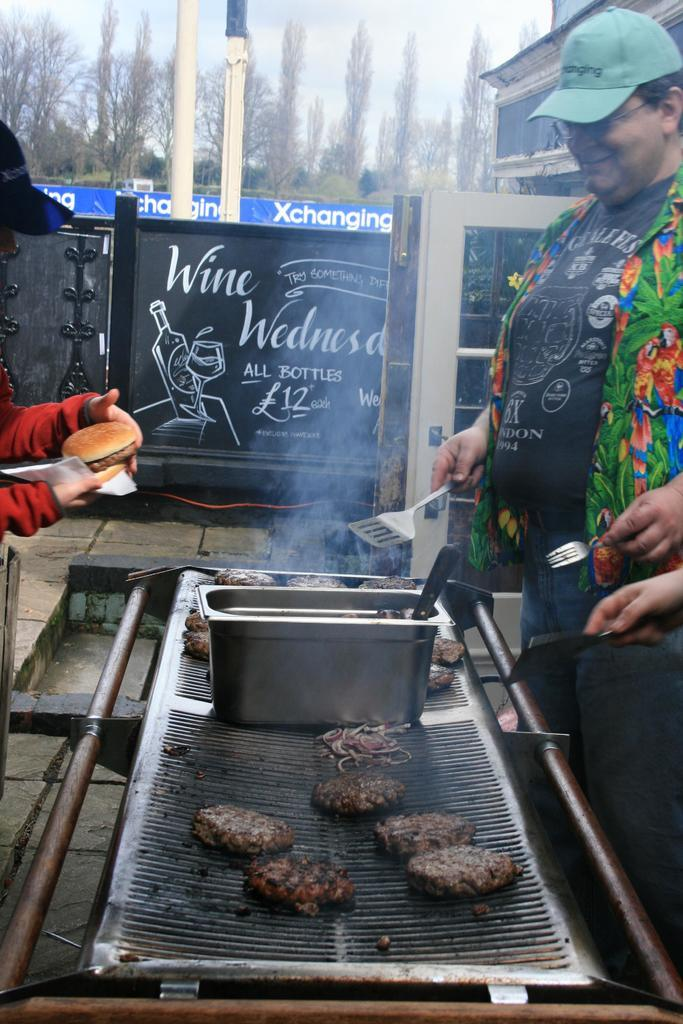<image>
Offer a succinct explanation of the picture presented. men are cooking burger patties on a smoking grill next to a sign that says "wine wednesday." 